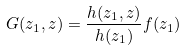Convert formula to latex. <formula><loc_0><loc_0><loc_500><loc_500>G ( z _ { 1 } , z ) = \frac { h ( z _ { 1 } , z ) } { h ( z _ { 1 } ) } f ( z _ { 1 } )</formula> 